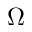Convert formula to latex. <formula><loc_0><loc_0><loc_500><loc_500>\Omega</formula> 